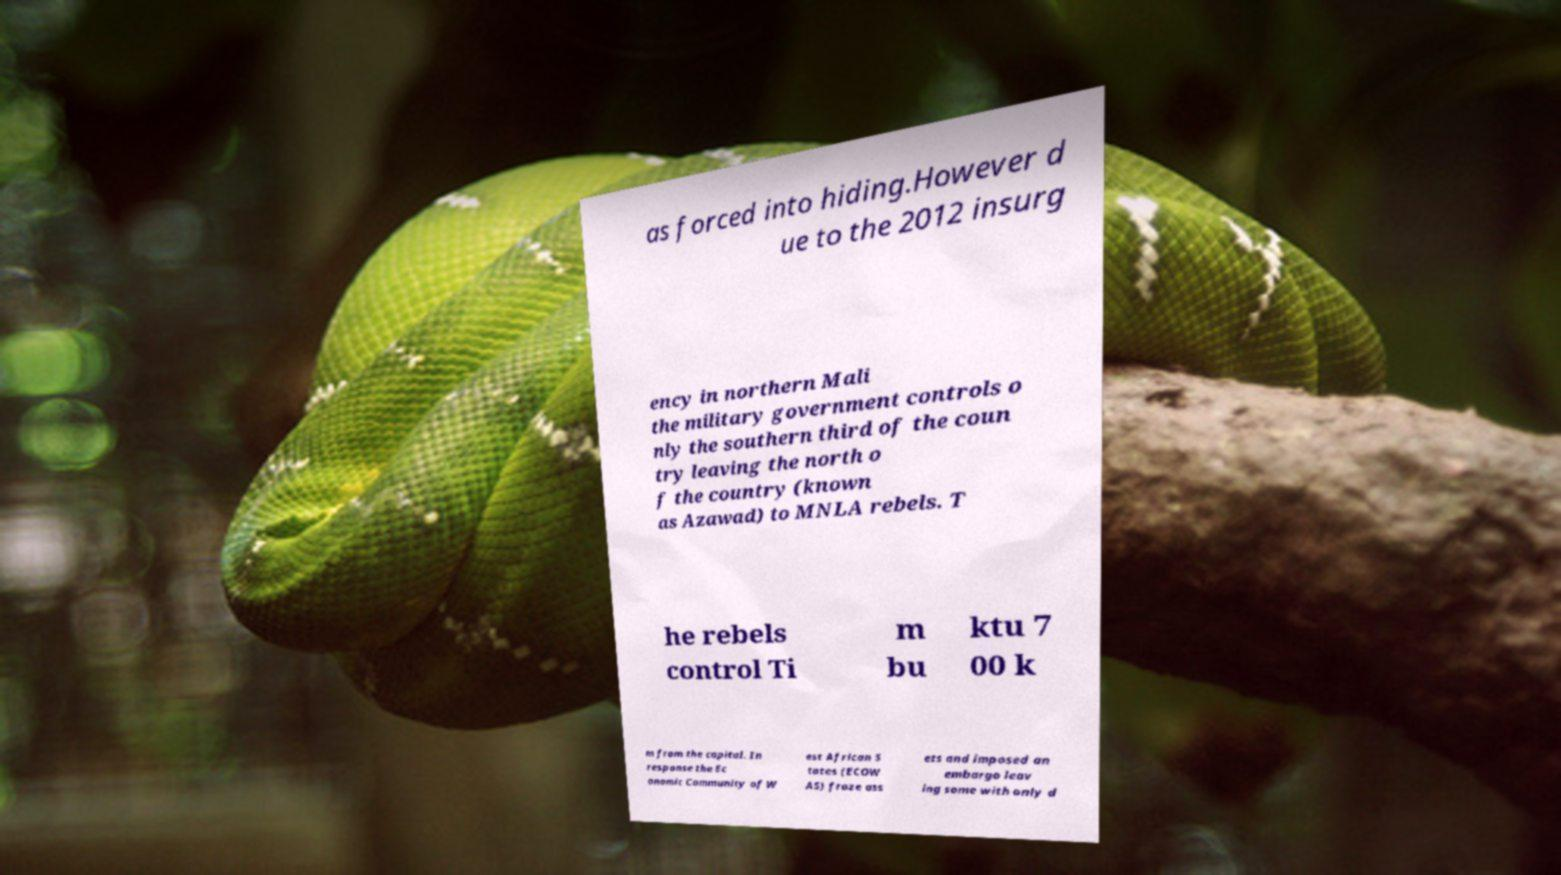Can you read and provide the text displayed in the image?This photo seems to have some interesting text. Can you extract and type it out for me? as forced into hiding.However d ue to the 2012 insurg ency in northern Mali the military government controls o nly the southern third of the coun try leaving the north o f the country (known as Azawad) to MNLA rebels. T he rebels control Ti m bu ktu 7 00 k m from the capital. In response the Ec onomic Community of W est African S tates (ECOW AS) froze ass ets and imposed an embargo leav ing some with only d 